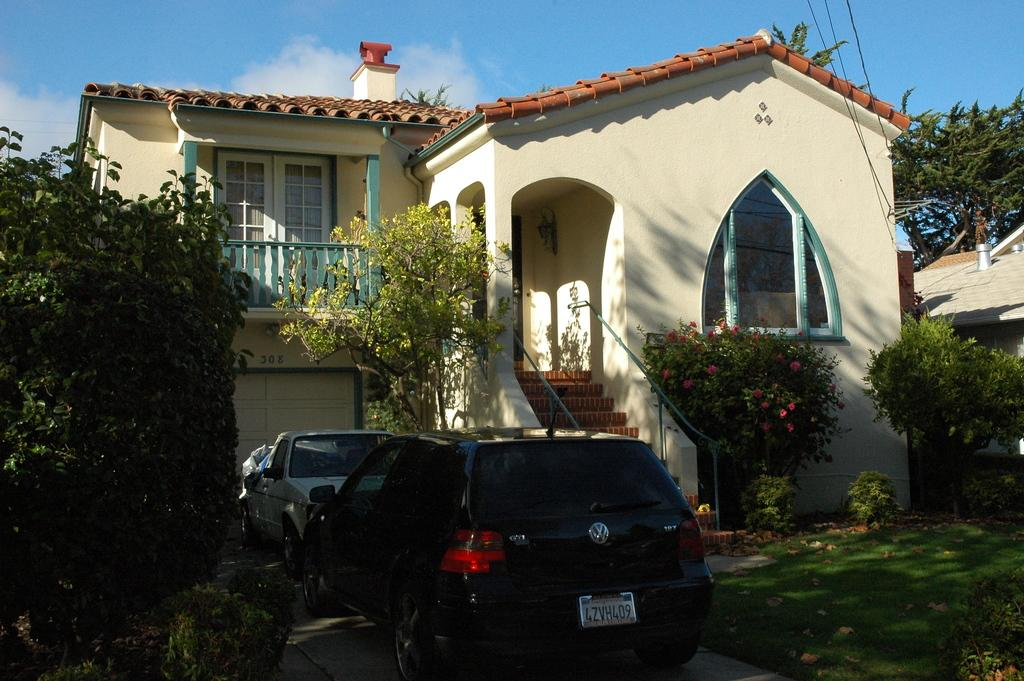What type of structures can be seen in the image? There are houses in the image. What else is visible in front of the houses? Two vehicles are parked in front of the houses. What type of vegetation is present around the plants? There are flowers around the plants. What other natural elements can be seen in the image? Trees and grass are visible in the image. What historical event is being commemorated by the flowers in the image? There is no indication of a historical event being commemorated by the flowers in the image. 